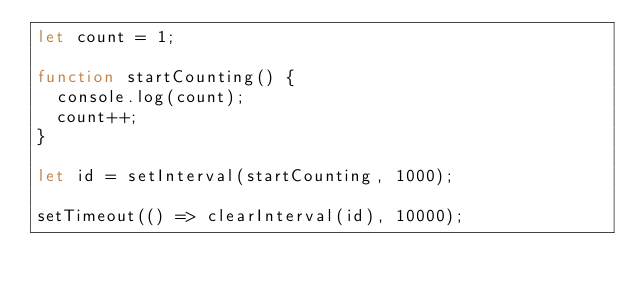Convert code to text. <code><loc_0><loc_0><loc_500><loc_500><_JavaScript_>let count = 1;

function startCounting() {
  console.log(count);
  count++;
}

let id = setInterval(startCounting, 1000);

setTimeout(() => clearInterval(id), 10000);
</code> 